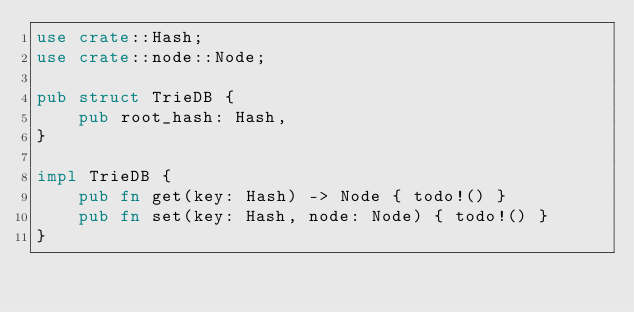Convert code to text. <code><loc_0><loc_0><loc_500><loc_500><_Rust_>use crate::Hash;
use crate::node::Node;

pub struct TrieDB {
    pub root_hash: Hash,
}

impl TrieDB {
    pub fn get(key: Hash) -> Node { todo!() }  
    pub fn set(key: Hash, node: Node) { todo!() }
}</code> 